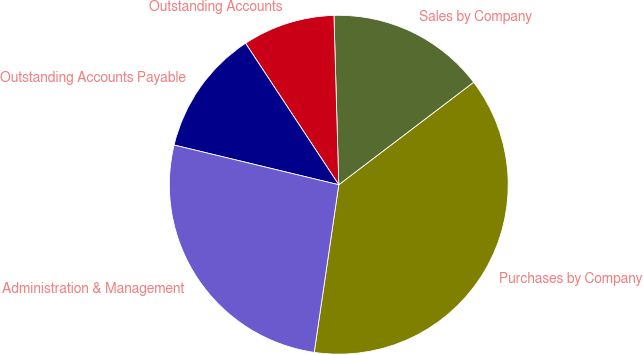<chart> <loc_0><loc_0><loc_500><loc_500><pie_chart><fcel>Purchases by Company<fcel>Sales by Company<fcel>Outstanding Accounts<fcel>Outstanding Accounts Payable<fcel>Administration & Management<nl><fcel>37.66%<fcel>15.11%<fcel>8.82%<fcel>11.96%<fcel>26.45%<nl></chart> 